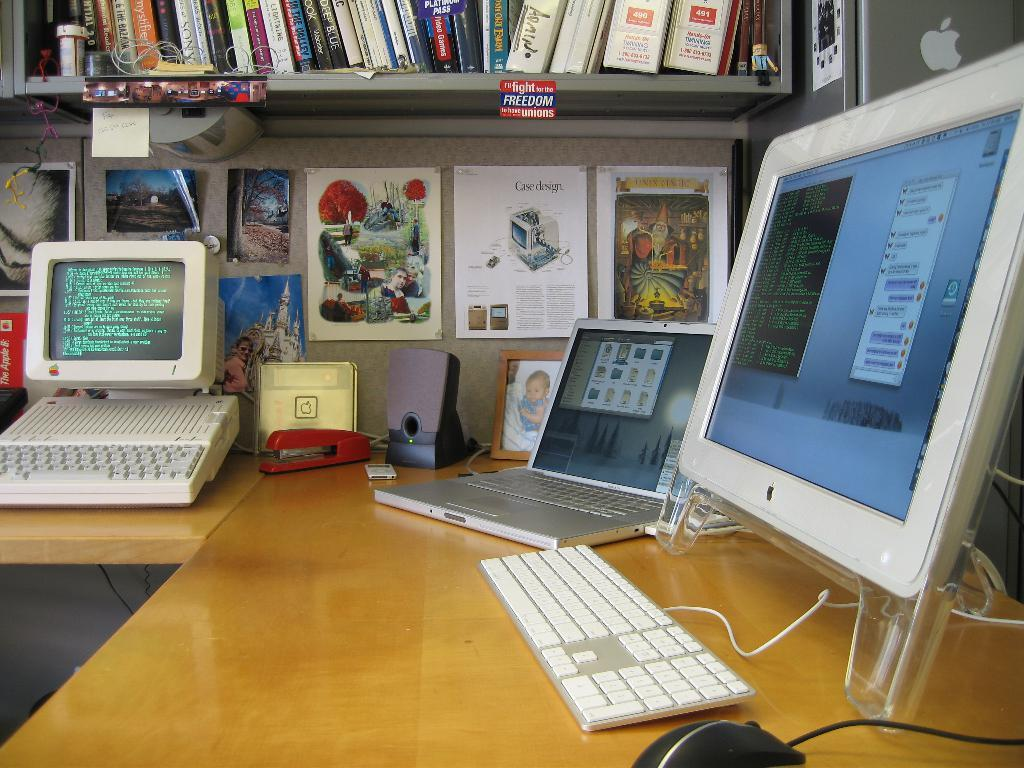What is on the rack in the image? There is a rack full of books in the image. What is on the table in the image? There is a monitor and a laptop on the table in the image. What can be seen on the wall in the image? There are paintings on the wall in the image. What type of zipper can be seen on the paintings in the image? There are no zippers present on the paintings in the image. What riddle is being solved on the monitor in the image? There is no riddle being solved on the monitor in the image; it is simply displaying something. What does the person in the image regret? There is no person present in the image, so it is impossible to determine if they have any regrets. 